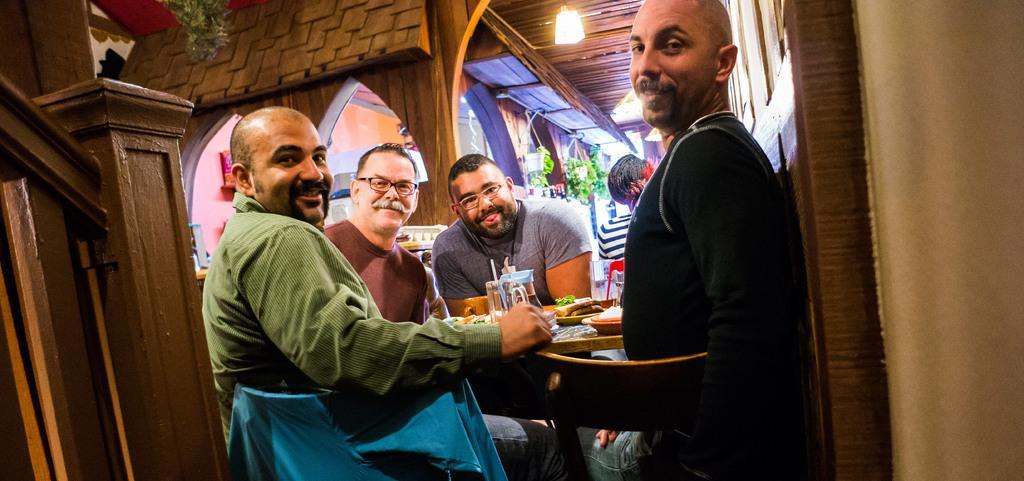Can you describe this image briefly? In the middle of the image few people are sitting and smiling and there is a table, on the table there are some plates and food and jars. Behind them there is a wooden wall. At the top of the image there is a wooden roof and light. 